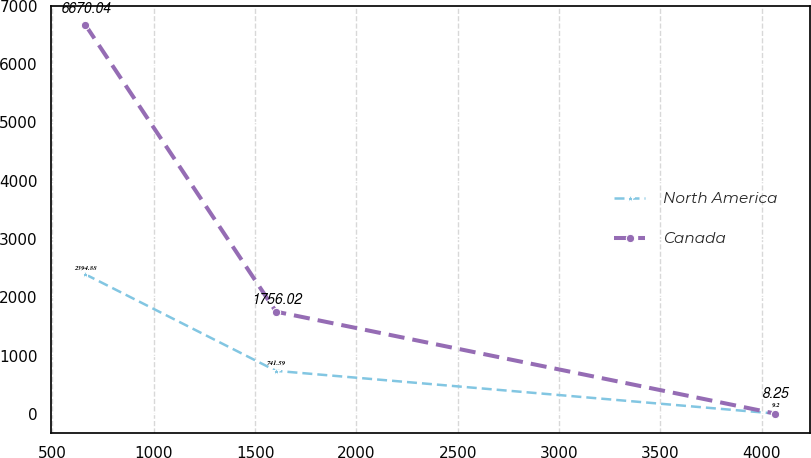Convert chart. <chart><loc_0><loc_0><loc_500><loc_500><line_chart><ecel><fcel>North America<fcel>Canada<nl><fcel>662.85<fcel>2394.88<fcel>6670.04<nl><fcel>1603.39<fcel>741.59<fcel>1756.02<nl><fcel>4068.38<fcel>9.2<fcel>8.25<nl></chart> 